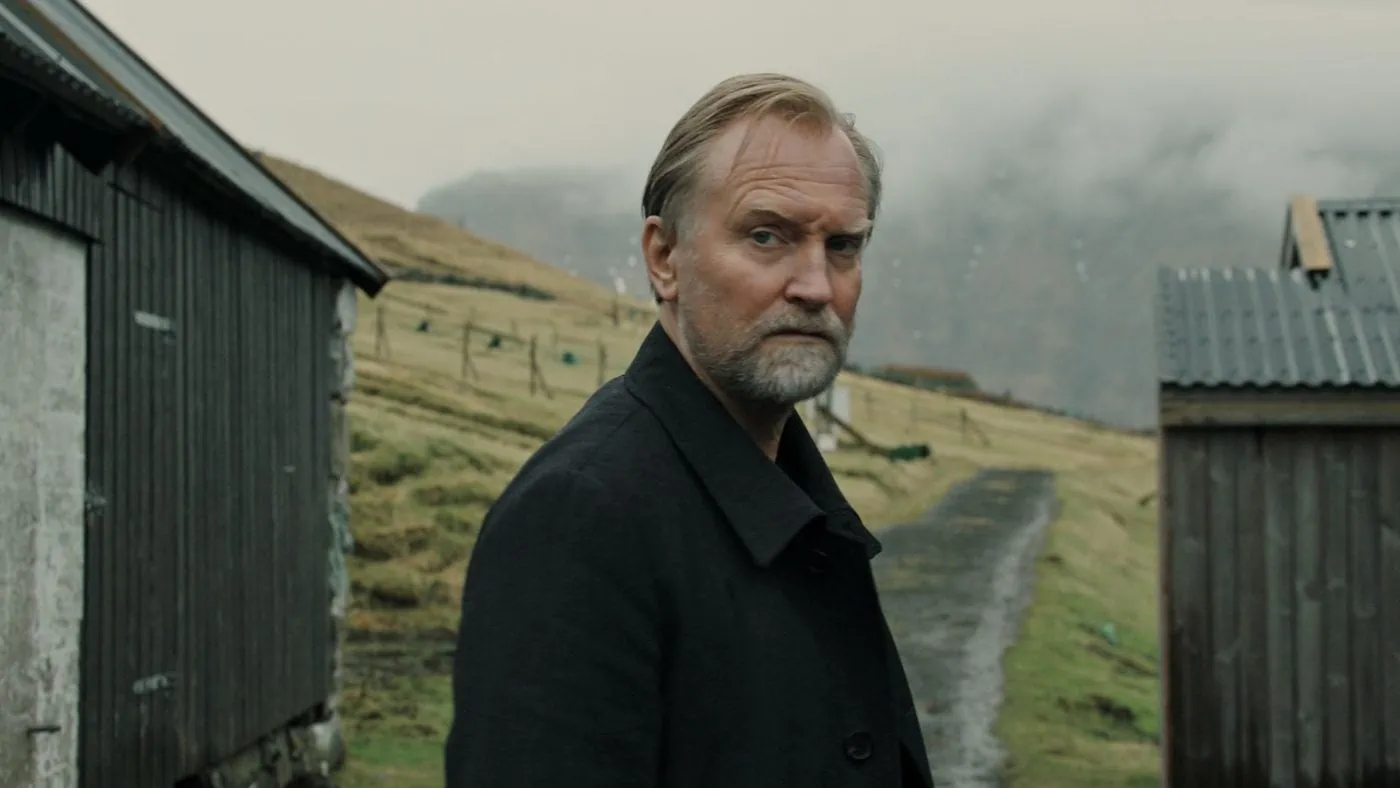Imagine what the man in the picture might be thinking about. The man in the picture might be deeply engrossed in thoughts about his past. Perhaps he is reminiscing about his childhood, recalling the games he played in these fields, the friendships forged and lost. He could be pondering a significant life decision he once made, weighing its impact on his current life. It's also possible that he is reflecting on the passage of time, and the changes that have occurred both within him and in the world around him. The serene yet somber setting amplifies his state of introspection, suggesting thoughts that are both wistful and profound. 